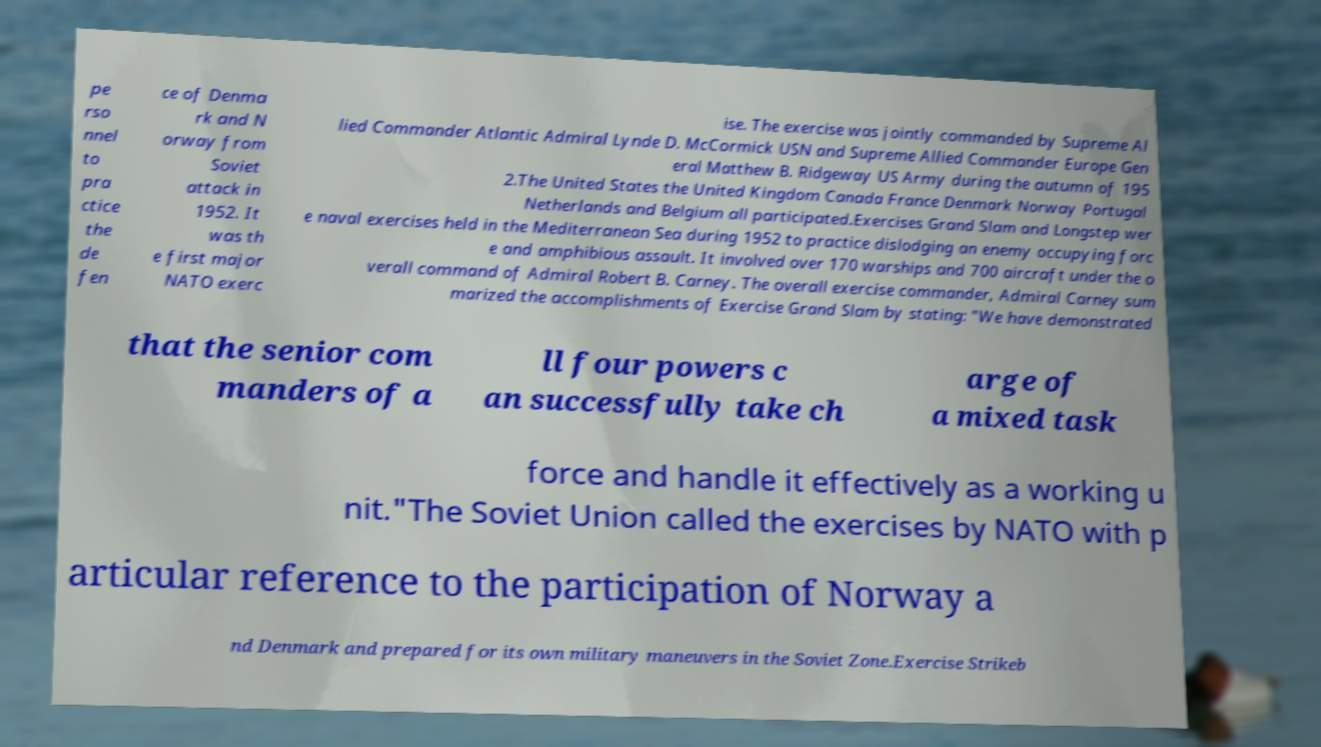For documentation purposes, I need the text within this image transcribed. Could you provide that? pe rso nnel to pra ctice the de fen ce of Denma rk and N orway from Soviet attack in 1952. It was th e first major NATO exerc ise. The exercise was jointly commanded by Supreme Al lied Commander Atlantic Admiral Lynde D. McCormick USN and Supreme Allied Commander Europe Gen eral Matthew B. Ridgeway US Army during the autumn of 195 2.The United States the United Kingdom Canada France Denmark Norway Portugal Netherlands and Belgium all participated.Exercises Grand Slam and Longstep wer e naval exercises held in the Mediterranean Sea during 1952 to practice dislodging an enemy occupying forc e and amphibious assault. It involved over 170 warships and 700 aircraft under the o verall command of Admiral Robert B. Carney. The overall exercise commander, Admiral Carney sum marized the accomplishments of Exercise Grand Slam by stating: "We have demonstrated that the senior com manders of a ll four powers c an successfully take ch arge of a mixed task force and handle it effectively as a working u nit."The Soviet Union called the exercises by NATO with p articular reference to the participation of Norway a nd Denmark and prepared for its own military maneuvers in the Soviet Zone.Exercise Strikeb 